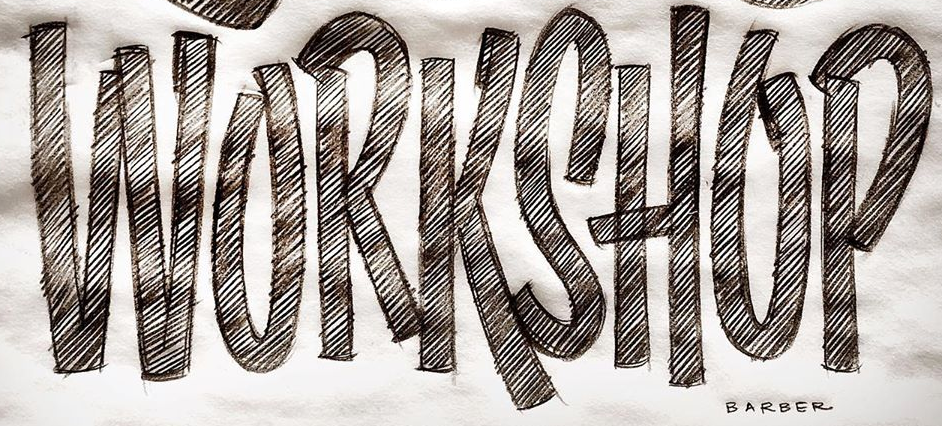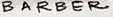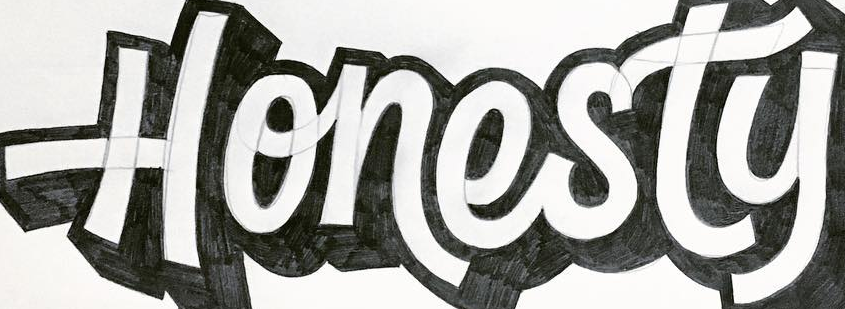What words are shown in these images in order, separated by a semicolon? WORKSHOP; BARBER; Honesty 